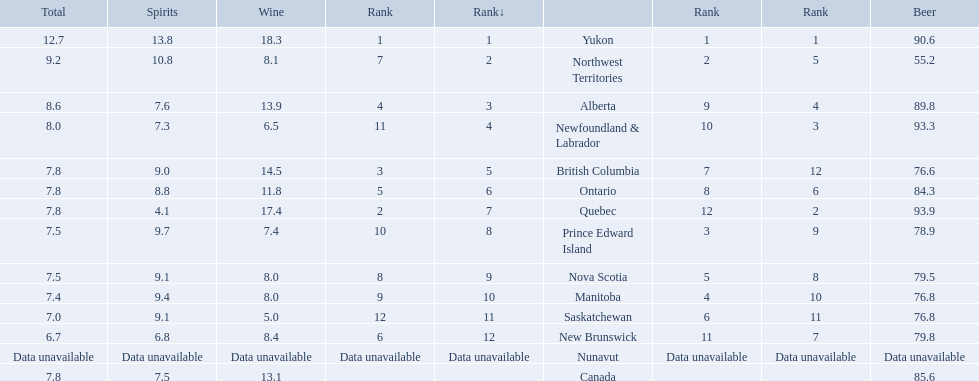What is the first ranked alcoholic beverage in canada Yukon. How many litters is consumed a year? 12.7. 